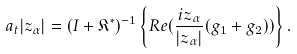<formula> <loc_0><loc_0><loc_500><loc_500>a _ { t } | z _ { \alpha } | = ( I + \mathfrak { K } ^ { \ast } ) ^ { - 1 } \left \{ R e ( \frac { i z _ { \alpha } } { | z _ { \alpha } | } ( g _ { 1 } + g _ { 2 } ) ) \right \} .</formula> 